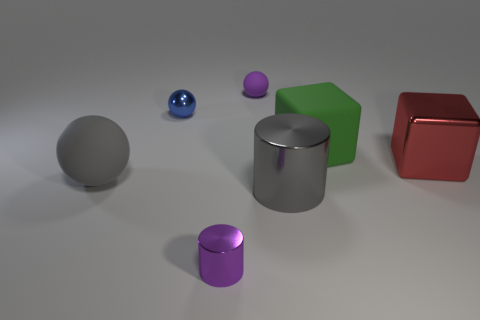Add 2 large cyan blocks. How many objects exist? 9 Subtract all cylinders. How many objects are left? 5 Subtract all green things. Subtract all large gray spheres. How many objects are left? 5 Add 3 tiny purple objects. How many tiny purple objects are left? 5 Add 3 tiny gray metal objects. How many tiny gray metal objects exist? 3 Subtract 0 blue blocks. How many objects are left? 7 